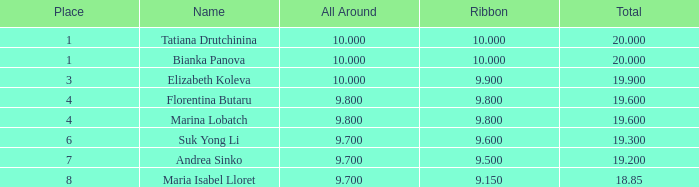What place had a ribbon below 9.8 and a 19.2 total? 7.0. 